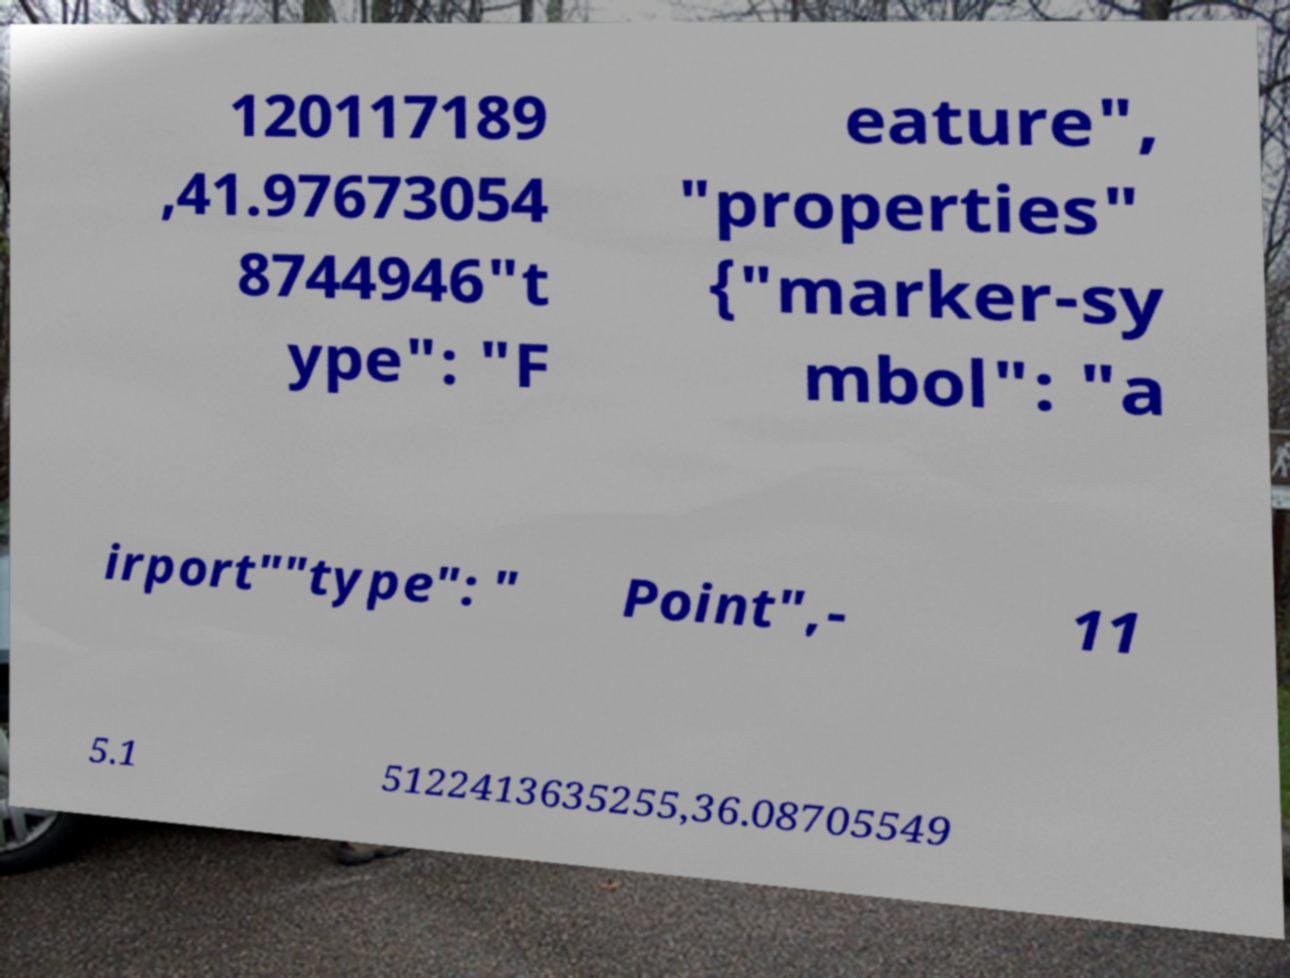Please read and relay the text visible in this image. What does it say? 120117189 ,41.97673054 8744946"t ype": "F eature", "properties" {"marker-sy mbol": "a irport""type": " Point",- 11 5.1 5122413635255,36.08705549 